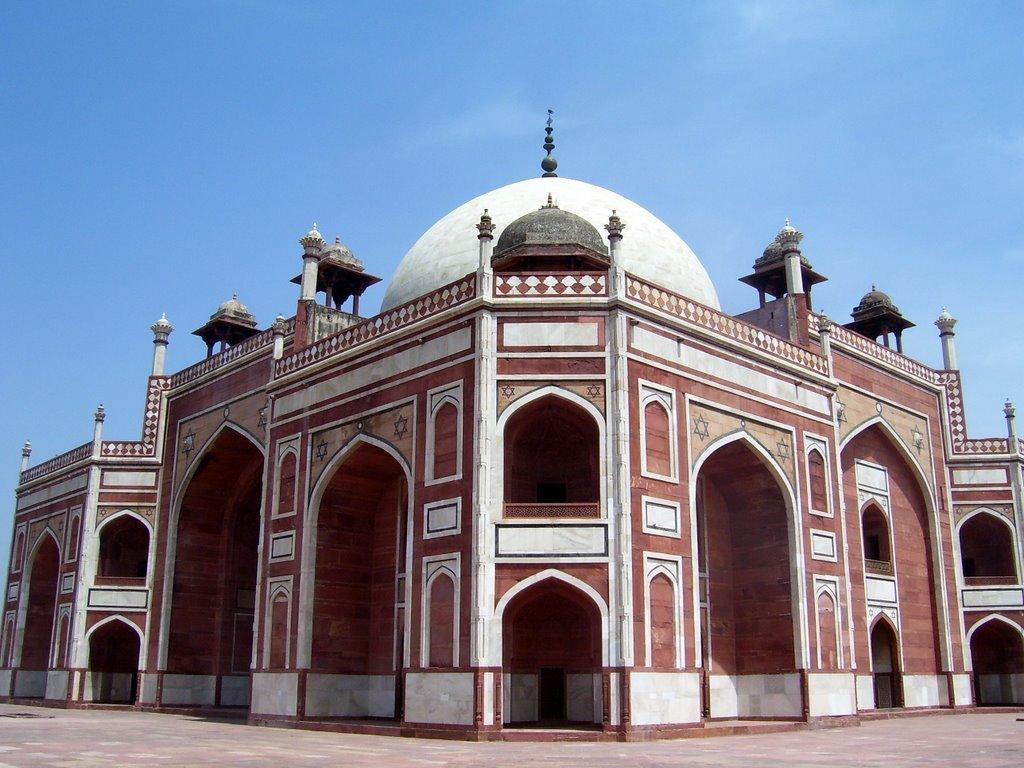What type of building is in the picture? There is an old mosque in the picture. What colors can be seen on the mosque? The mosque has a brown and white color. What architectural feature is present on the mosque? The mosque has a dome. What is the color of the sky in the image? The sky is blue in the image. Can you see a mitten hanging on the mosque in the image? No, there is no mitten present in the image. What type of leather is used to make the basketball in the image? There is no basketball present in the image. 